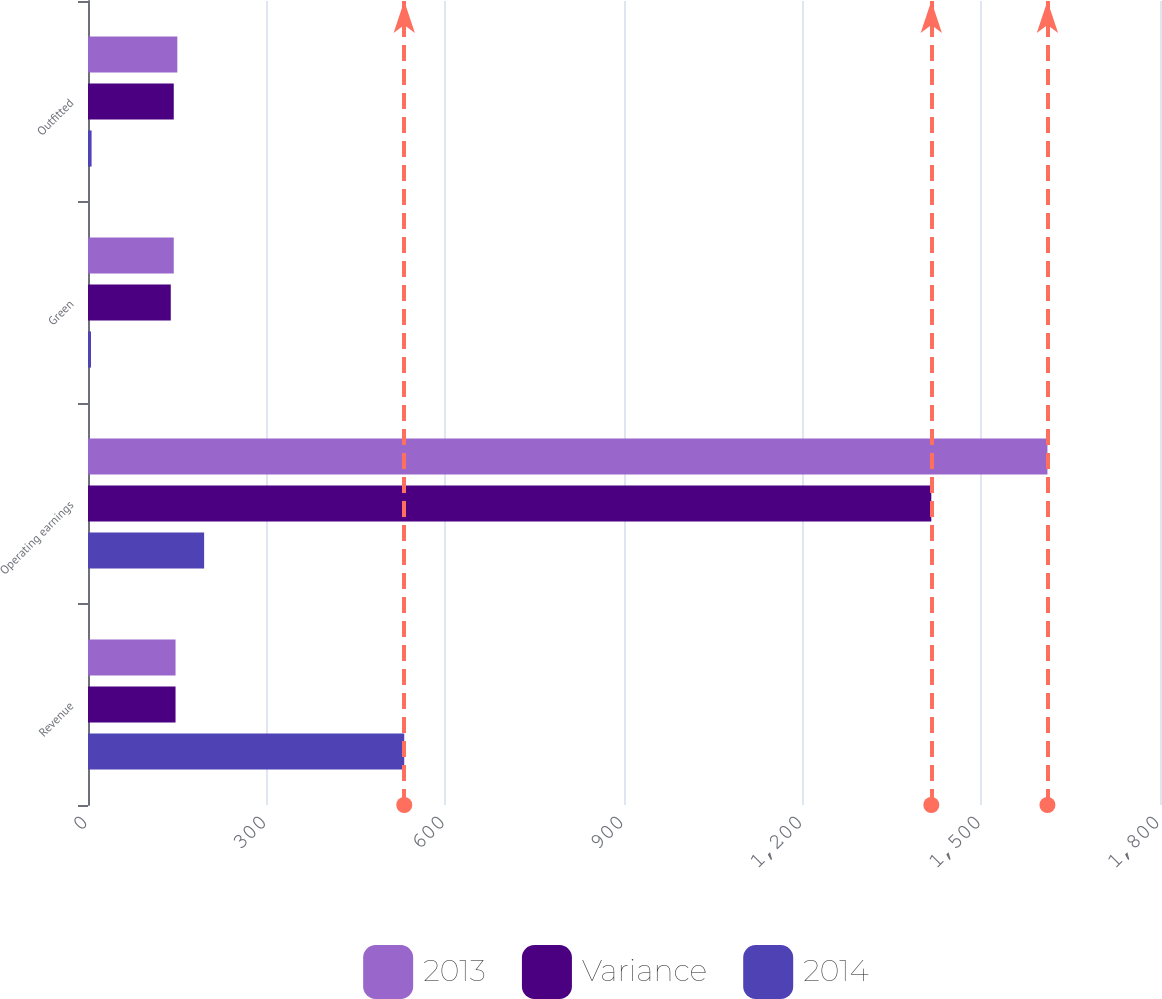Convert chart to OTSL. <chart><loc_0><loc_0><loc_500><loc_500><stacked_bar_chart><ecel><fcel>Revenue<fcel>Operating earnings<fcel>Green<fcel>Outfitted<nl><fcel>2013<fcel>147<fcel>1611<fcel>144<fcel>150<nl><fcel>Variance<fcel>147<fcel>1416<fcel>139<fcel>144<nl><fcel>2014<fcel>531<fcel>195<fcel>5<fcel>6<nl></chart> 